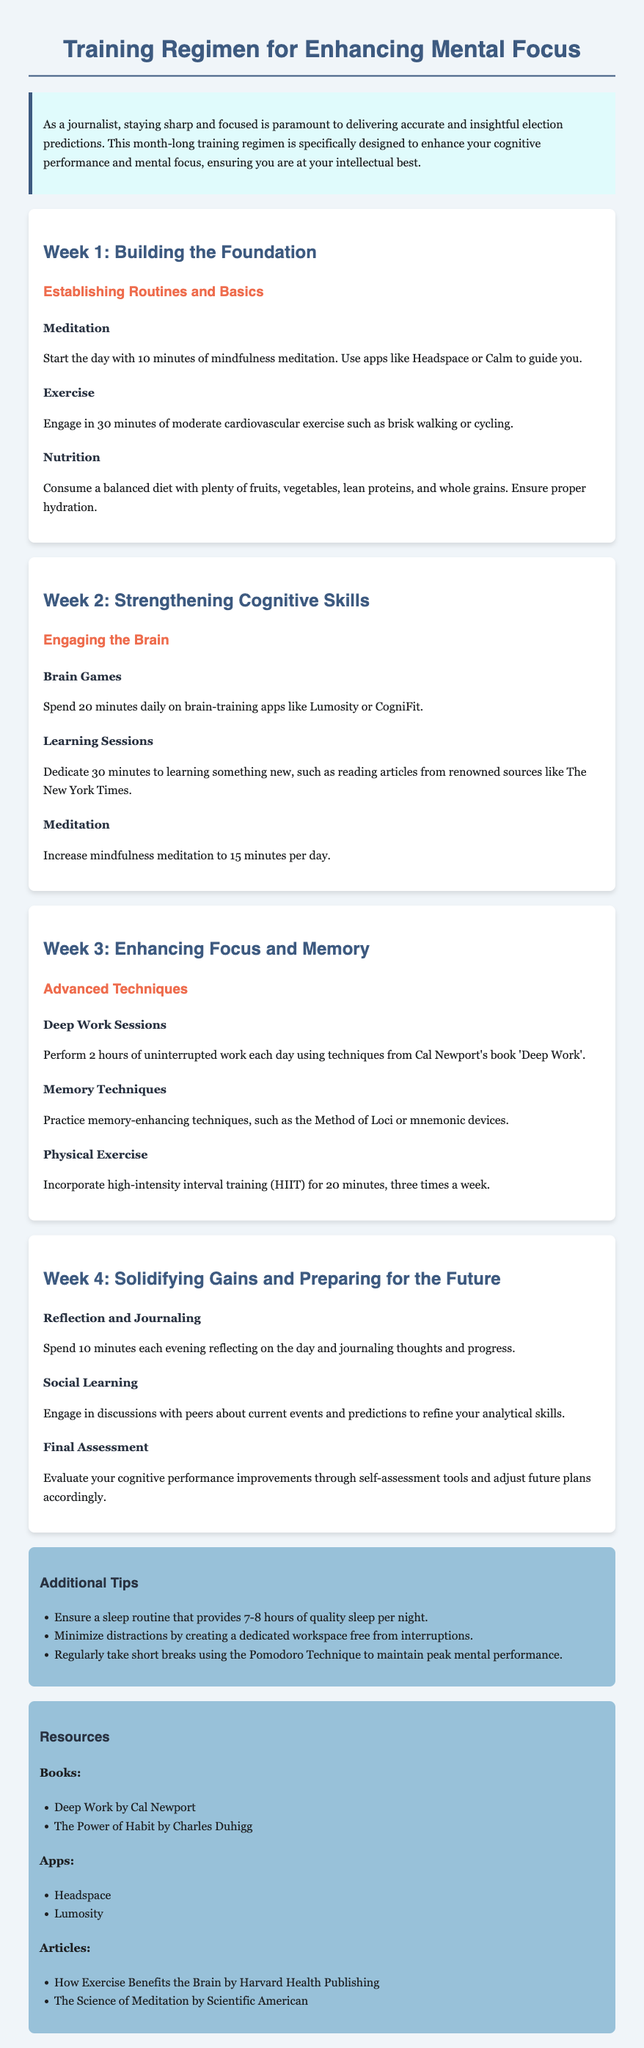What is the duration of meditation in Week 1? The duration of meditation in Week 1 is specified as starting the day with 10 minutes of mindfulness meditation.
Answer: 10 minutes What type of exercise is suggested for Week 1? The document states that moderate cardiovascular exercise like brisk walking or cycling should be engaged in.
Answer: Cardiovascular exercise How many minutes of brain games should be spent daily in Week 2? The document mentions that 20 minutes daily should be spent on brain-training apps like Lumosity or CogniFit.
Answer: 20 minutes What technique should be used for deep work sessions in Week 3? The document recommends using techniques from Cal Newport's book 'Deep Work' for 2 hours of uninterrupted work.
Answer: Deep Work What is one activity suggested in Week 4 for reflection? The document suggests spending 10 minutes each evening reflecting on the day and journaling thoughts and progress.
Answer: Journaling How many hours of quality sleep should one aim for each night according to the tips? The document advises ensuring a sleep routine that provides 7-8 hours of quality sleep per night.
Answer: 7-8 hours What is the focus of Week 2? The document states that Week 2 focuses on strengthening cognitive skills through various engaging brain activities.
Answer: Strengthening Cognitive Skills Which app is mentioned for mindfulness meditation? The document lists Headspace as one of the apps to guide mindfulness meditation.
Answer: Headspace How many times a week should HIIT be incorporated? The document specifies incorporating high-intensity interval training (HIIT) for 20 minutes, three times a week.
Answer: Three times 